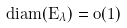Convert formula to latex. <formula><loc_0><loc_0><loc_500><loc_500>d i a m ( E _ { \lambda } ) = o ( 1 )</formula> 